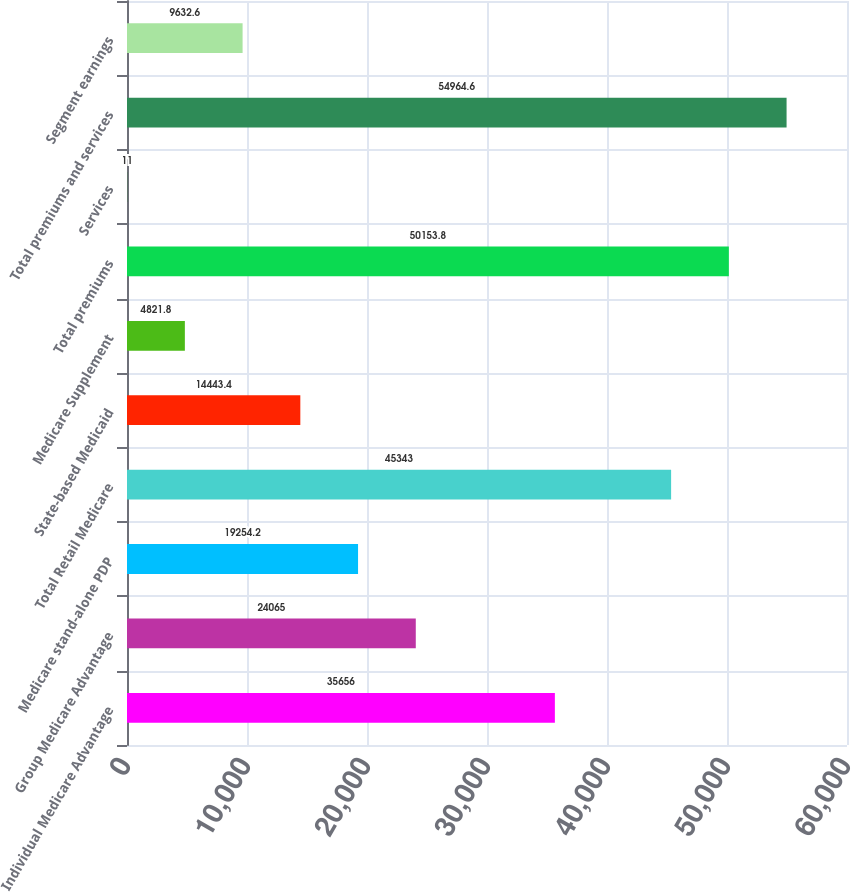<chart> <loc_0><loc_0><loc_500><loc_500><bar_chart><fcel>Individual Medicare Advantage<fcel>Group Medicare Advantage<fcel>Medicare stand-alone PDP<fcel>Total Retail Medicare<fcel>State-based Medicaid<fcel>Medicare Supplement<fcel>Total premiums<fcel>Services<fcel>Total premiums and services<fcel>Segment earnings<nl><fcel>35656<fcel>24065<fcel>19254.2<fcel>45343<fcel>14443.4<fcel>4821.8<fcel>50153.8<fcel>11<fcel>54964.6<fcel>9632.6<nl></chart> 